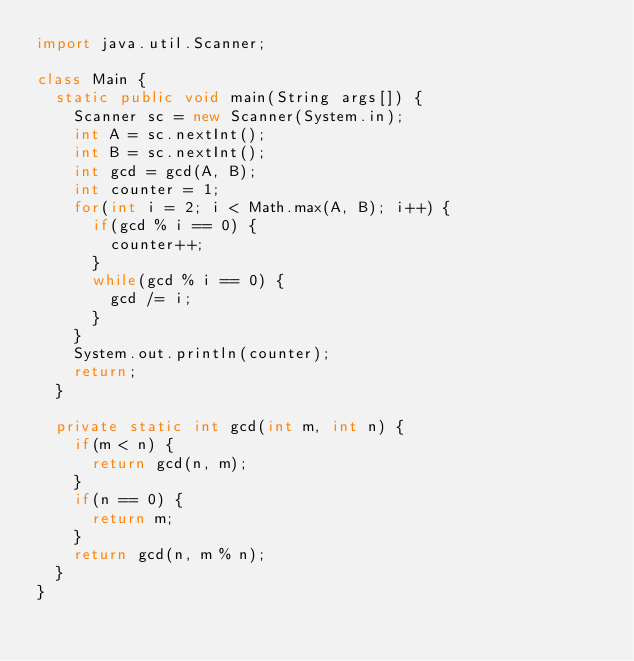<code> <loc_0><loc_0><loc_500><loc_500><_Java_>import java.util.Scanner;

class Main {
  static public void main(String args[]) {
    Scanner sc = new Scanner(System.in);
    int A = sc.nextInt();
    int B = sc.nextInt();
    int gcd = gcd(A, B);
    int counter = 1;
    for(int i = 2; i < Math.max(A, B); i++) {
      if(gcd % i == 0) {
        counter++;
      }
      while(gcd % i == 0) {
        gcd /= i;
      }
    }
    System.out.println(counter);
    return;
  }

  private static int gcd(int m, int n) {
    if(m < n) {
      return gcd(n, m);
    }
    if(n == 0) {
      return m;
    }
    return gcd(n, m % n);
  }
}
</code> 